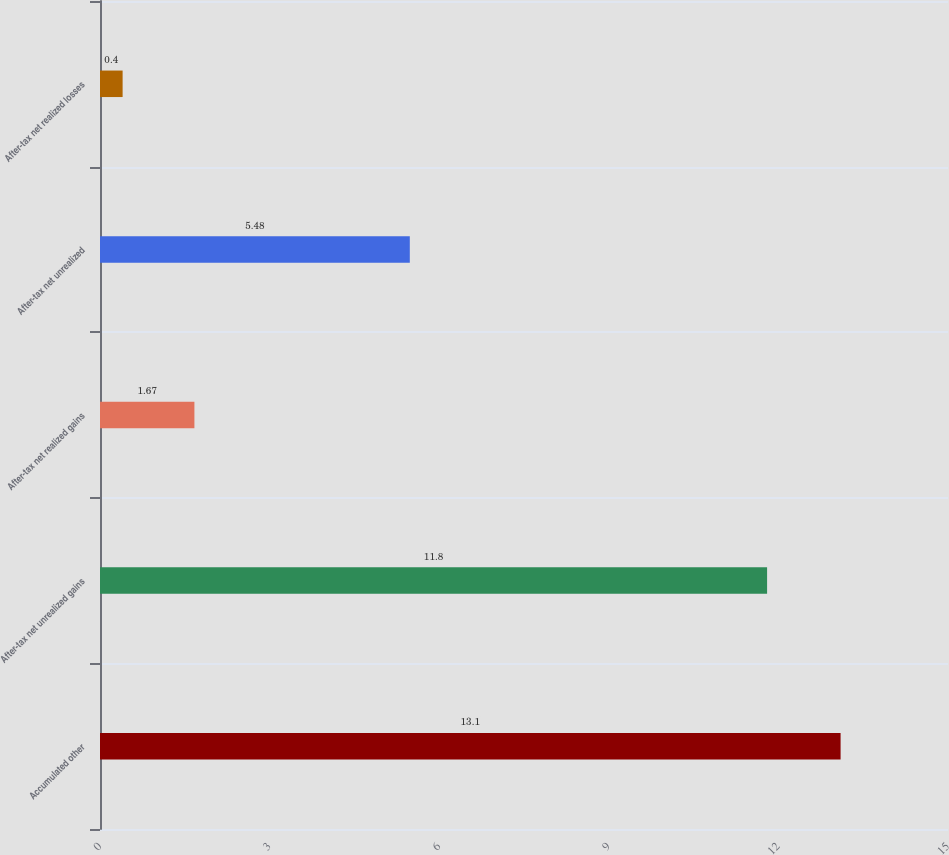Convert chart to OTSL. <chart><loc_0><loc_0><loc_500><loc_500><bar_chart><fcel>Accumulated other<fcel>After-tax net unrealized gains<fcel>After-tax net realized gains<fcel>After-tax net unrealized<fcel>After-tax net realized losses<nl><fcel>13.1<fcel>11.8<fcel>1.67<fcel>5.48<fcel>0.4<nl></chart> 